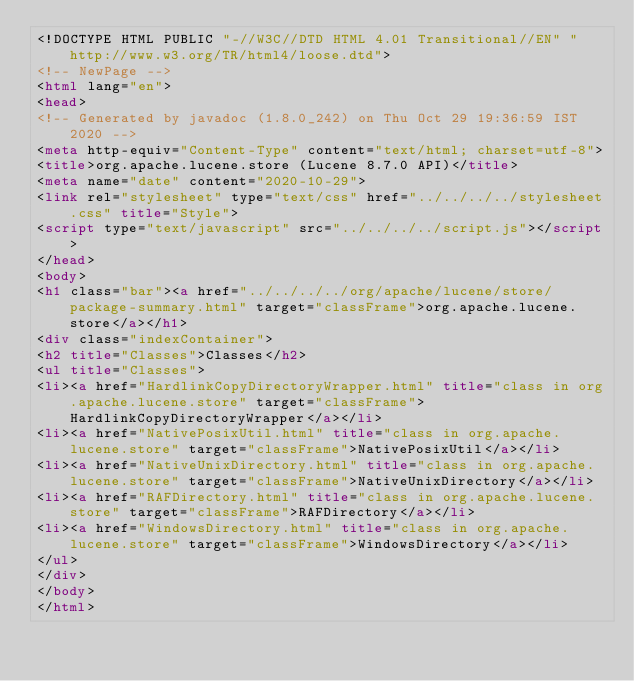<code> <loc_0><loc_0><loc_500><loc_500><_HTML_><!DOCTYPE HTML PUBLIC "-//W3C//DTD HTML 4.01 Transitional//EN" "http://www.w3.org/TR/html4/loose.dtd">
<!-- NewPage -->
<html lang="en">
<head>
<!-- Generated by javadoc (1.8.0_242) on Thu Oct 29 19:36:59 IST 2020 -->
<meta http-equiv="Content-Type" content="text/html; charset=utf-8">
<title>org.apache.lucene.store (Lucene 8.7.0 API)</title>
<meta name="date" content="2020-10-29">
<link rel="stylesheet" type="text/css" href="../../../../stylesheet.css" title="Style">
<script type="text/javascript" src="../../../../script.js"></script>
</head>
<body>
<h1 class="bar"><a href="../../../../org/apache/lucene/store/package-summary.html" target="classFrame">org.apache.lucene.store</a></h1>
<div class="indexContainer">
<h2 title="Classes">Classes</h2>
<ul title="Classes">
<li><a href="HardlinkCopyDirectoryWrapper.html" title="class in org.apache.lucene.store" target="classFrame">HardlinkCopyDirectoryWrapper</a></li>
<li><a href="NativePosixUtil.html" title="class in org.apache.lucene.store" target="classFrame">NativePosixUtil</a></li>
<li><a href="NativeUnixDirectory.html" title="class in org.apache.lucene.store" target="classFrame">NativeUnixDirectory</a></li>
<li><a href="RAFDirectory.html" title="class in org.apache.lucene.store" target="classFrame">RAFDirectory</a></li>
<li><a href="WindowsDirectory.html" title="class in org.apache.lucene.store" target="classFrame">WindowsDirectory</a></li>
</ul>
</div>
</body>
</html>
</code> 